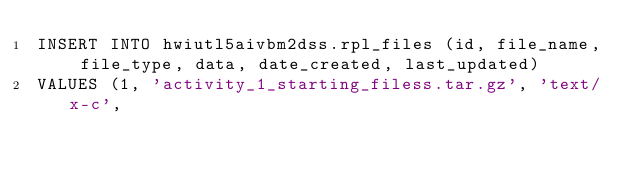Convert code to text. <code><loc_0><loc_0><loc_500><loc_500><_SQL_>INSERT INTO hwiutl5aivbm2dss.rpl_files (id, file_name, file_type, data, date_created, last_updated)
VALUES (1, 'activity_1_starting_filess.tar.gz', 'text/x-c',</code> 